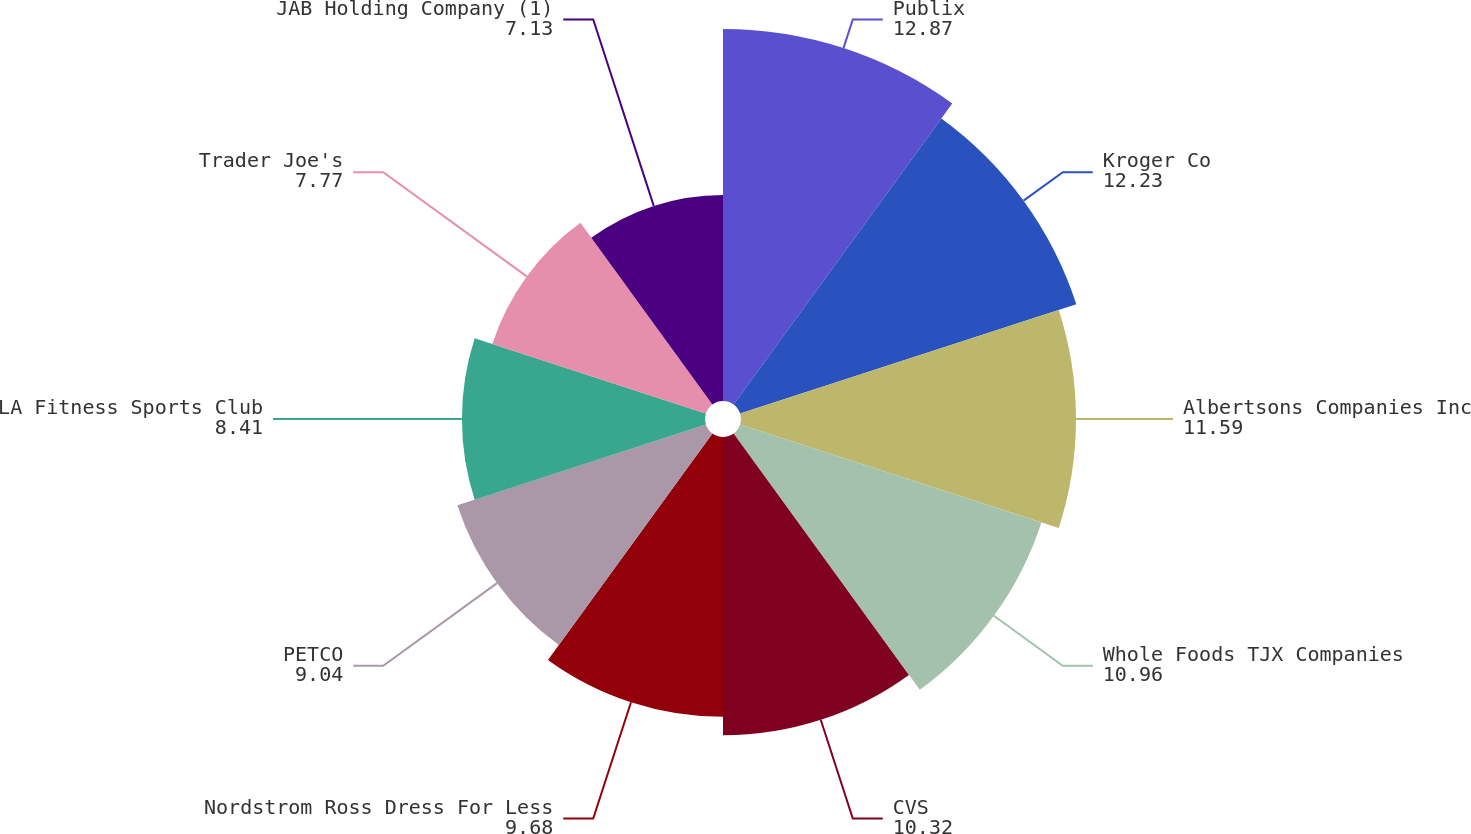Convert chart. <chart><loc_0><loc_0><loc_500><loc_500><pie_chart><fcel>Publix<fcel>Kroger Co<fcel>Albertsons Companies Inc<fcel>Whole Foods TJX Companies<fcel>CVS<fcel>Nordstrom Ross Dress For Less<fcel>PETCO<fcel>LA Fitness Sports Club<fcel>Trader Joe's<fcel>JAB Holding Company (1)<nl><fcel>12.87%<fcel>12.23%<fcel>11.59%<fcel>10.96%<fcel>10.32%<fcel>9.68%<fcel>9.04%<fcel>8.41%<fcel>7.77%<fcel>7.13%<nl></chart> 